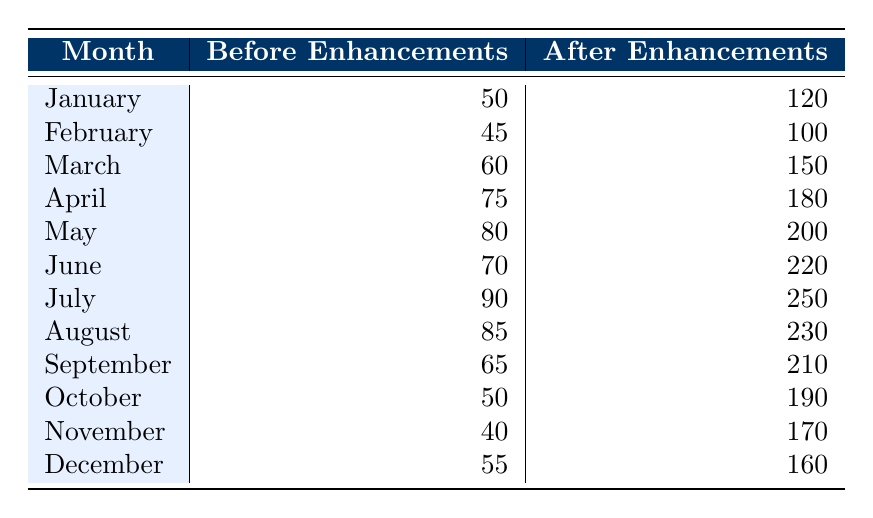What was the usage of the outdoor space in April before the enhancements? In the table, the value listed for "Before Enhancements" in April indicates the usage count, which is 75.
Answer: 75 What is the total usage of the outdoor space during the month of July after enhancements? The value in the "After Enhancements" column for July shows the usage count of 250.
Answer: 250 How many more people used the outdoor space in May after the enhancements compared to before? To find the difference, subtract the "Before Enhancements" for May (80) from "After Enhancements" for May (200). 200 - 80 = 120.
Answer: 120 What was the average outdoor space usage before enhancements over the entire year? To calculate the average, sum the "Before Enhancements" counts for all months (50 + 45 + 60 + 75 + 80 + 70 + 90 + 85 + 65 + 50 + 40 + 55 =  735) and divide by the number of months (12), giving 735 / 12 = 61.25.
Answer: 61.25 Did the outdoor space usage after enhancements in February exceed 100? In the table, the usage after enhancements for February is 100, so it did not exceed it.
Answer: No How does the usage in June after enhancements compare to the usage in January before enhancements? The usage in June after enhancements is 220, while usage in January before enhancements is 50. 220 is greater than 50.
Answer: June usage is greater What was the maximum increase in usage of outdoor space after enhancements compared to before any month? To determine this, look for the largest difference between the "Before Enhancements" and "After Enhancements." The differences are (120 - 50), (100 - 45), (150 - 60), (180 - 75), (200 - 80), (220 - 70), (250 - 90), (230 - 85), (210 - 65), (190 - 50), (170 - 40), (160 - 55). The largest difference is 250 - 90 = 160.
Answer: 160 How many months saw a decrease in outdoor space usage after enhancements compared to before? By comparing the values in both columns for each month, none of the months showed a decrease; all values after enhancements are higher than or the same as before.
Answer: 0 What was the total outdoor space usage in December before the enhancements? From the table, the "Before Enhancements" usage for December is 55.
Answer: 55 